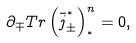<formula> <loc_0><loc_0><loc_500><loc_500>\partial _ { \mp } T r \left ( \bar { j } _ { \pm } ^ { ^ { * } } \right ) _ { ^ { * } } ^ { n } = 0 ,</formula> 